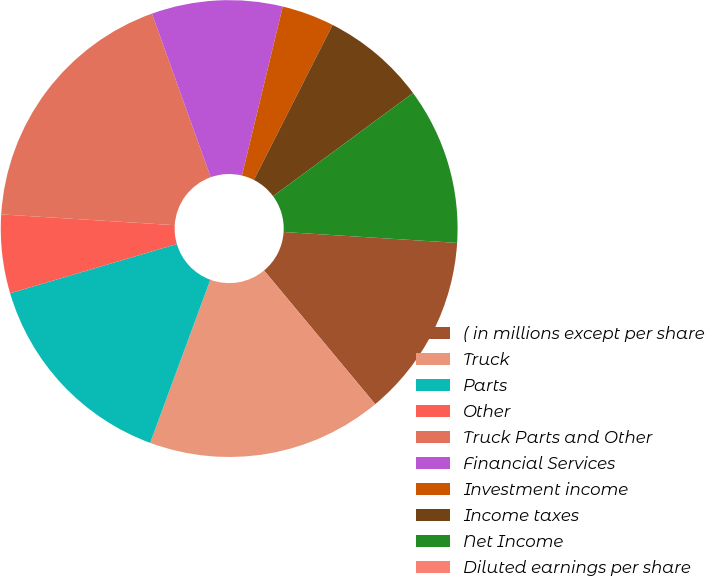Convert chart. <chart><loc_0><loc_0><loc_500><loc_500><pie_chart><fcel>( in millions except per share<fcel>Truck<fcel>Parts<fcel>Other<fcel>Truck Parts and Other<fcel>Financial Services<fcel>Investment income<fcel>Income taxes<fcel>Net Income<fcel>Diluted earnings per share<nl><fcel>12.96%<fcel>16.66%<fcel>14.81%<fcel>5.56%<fcel>18.52%<fcel>9.26%<fcel>3.71%<fcel>7.41%<fcel>11.11%<fcel>0.0%<nl></chart> 